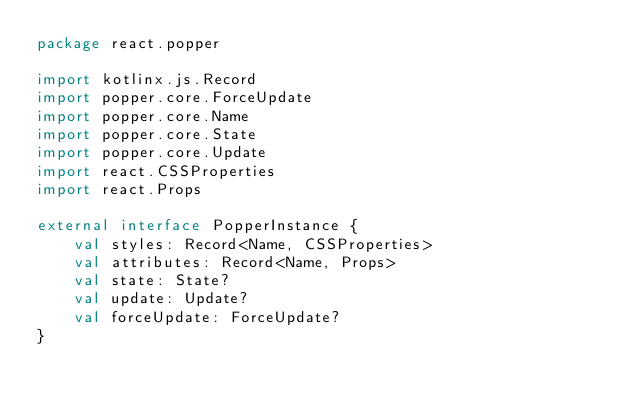Convert code to text. <code><loc_0><loc_0><loc_500><loc_500><_Kotlin_>package react.popper

import kotlinx.js.Record
import popper.core.ForceUpdate
import popper.core.Name
import popper.core.State
import popper.core.Update
import react.CSSProperties
import react.Props

external interface PopperInstance {
    val styles: Record<Name, CSSProperties>
    val attributes: Record<Name, Props>
    val state: State?
    val update: Update?
    val forceUpdate: ForceUpdate?
}
</code> 